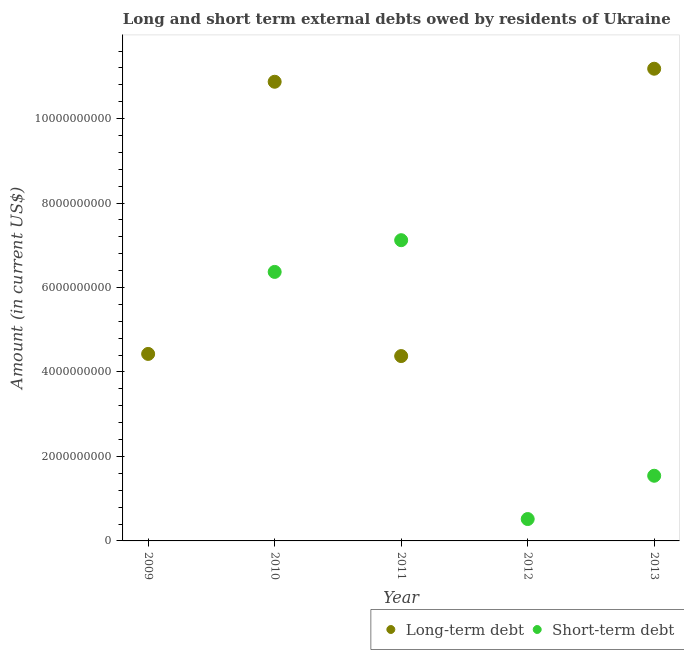What is the long-term debts owed by residents in 2010?
Offer a very short reply. 1.09e+1. Across all years, what is the maximum long-term debts owed by residents?
Provide a succinct answer. 1.12e+1. Across all years, what is the minimum short-term debts owed by residents?
Make the answer very short. 0. In which year was the long-term debts owed by residents maximum?
Keep it short and to the point. 2013. What is the total long-term debts owed by residents in the graph?
Offer a terse response. 3.09e+1. What is the difference between the long-term debts owed by residents in 2009 and that in 2010?
Provide a short and direct response. -6.44e+09. What is the difference between the long-term debts owed by residents in 2010 and the short-term debts owed by residents in 2009?
Your answer should be very brief. 1.09e+1. What is the average long-term debts owed by residents per year?
Your response must be concise. 6.17e+09. In the year 2013, what is the difference between the long-term debts owed by residents and short-term debts owed by residents?
Provide a succinct answer. 9.64e+09. In how many years, is the long-term debts owed by residents greater than 400000000 US$?
Offer a very short reply. 4. What is the ratio of the long-term debts owed by residents in 2010 to that in 2013?
Keep it short and to the point. 0.97. Is the short-term debts owed by residents in 2010 less than that in 2013?
Provide a short and direct response. No. What is the difference between the highest and the second highest long-term debts owed by residents?
Your answer should be very brief. 3.09e+08. What is the difference between the highest and the lowest long-term debts owed by residents?
Provide a succinct answer. 1.12e+1. Does the long-term debts owed by residents monotonically increase over the years?
Your response must be concise. No. Is the long-term debts owed by residents strictly less than the short-term debts owed by residents over the years?
Your answer should be compact. No. How many years are there in the graph?
Give a very brief answer. 5. What is the difference between two consecutive major ticks on the Y-axis?
Offer a very short reply. 2.00e+09. Are the values on the major ticks of Y-axis written in scientific E-notation?
Provide a short and direct response. No. Does the graph contain any zero values?
Ensure brevity in your answer.  Yes. Where does the legend appear in the graph?
Give a very brief answer. Bottom right. What is the title of the graph?
Offer a terse response. Long and short term external debts owed by residents of Ukraine. What is the Amount (in current US$) of Long-term debt in 2009?
Ensure brevity in your answer.  4.43e+09. What is the Amount (in current US$) of Long-term debt in 2010?
Your answer should be very brief. 1.09e+1. What is the Amount (in current US$) in Short-term debt in 2010?
Your answer should be compact. 6.37e+09. What is the Amount (in current US$) in Long-term debt in 2011?
Offer a terse response. 4.38e+09. What is the Amount (in current US$) in Short-term debt in 2011?
Provide a succinct answer. 7.12e+09. What is the Amount (in current US$) in Long-term debt in 2012?
Ensure brevity in your answer.  0. What is the Amount (in current US$) in Short-term debt in 2012?
Provide a short and direct response. 5.18e+08. What is the Amount (in current US$) in Long-term debt in 2013?
Give a very brief answer. 1.12e+1. What is the Amount (in current US$) of Short-term debt in 2013?
Keep it short and to the point. 1.54e+09. Across all years, what is the maximum Amount (in current US$) in Long-term debt?
Provide a succinct answer. 1.12e+1. Across all years, what is the maximum Amount (in current US$) of Short-term debt?
Provide a succinct answer. 7.12e+09. Across all years, what is the minimum Amount (in current US$) in Long-term debt?
Ensure brevity in your answer.  0. Across all years, what is the minimum Amount (in current US$) in Short-term debt?
Make the answer very short. 0. What is the total Amount (in current US$) in Long-term debt in the graph?
Make the answer very short. 3.09e+1. What is the total Amount (in current US$) in Short-term debt in the graph?
Your response must be concise. 1.56e+1. What is the difference between the Amount (in current US$) of Long-term debt in 2009 and that in 2010?
Provide a short and direct response. -6.44e+09. What is the difference between the Amount (in current US$) in Long-term debt in 2009 and that in 2011?
Offer a terse response. 5.08e+07. What is the difference between the Amount (in current US$) of Long-term debt in 2009 and that in 2013?
Offer a terse response. -6.75e+09. What is the difference between the Amount (in current US$) of Long-term debt in 2010 and that in 2011?
Your answer should be compact. 6.50e+09. What is the difference between the Amount (in current US$) of Short-term debt in 2010 and that in 2011?
Offer a terse response. -7.51e+08. What is the difference between the Amount (in current US$) of Short-term debt in 2010 and that in 2012?
Offer a very short reply. 5.85e+09. What is the difference between the Amount (in current US$) of Long-term debt in 2010 and that in 2013?
Offer a terse response. -3.09e+08. What is the difference between the Amount (in current US$) in Short-term debt in 2010 and that in 2013?
Your answer should be compact. 4.83e+09. What is the difference between the Amount (in current US$) of Short-term debt in 2011 and that in 2012?
Offer a very short reply. 6.60e+09. What is the difference between the Amount (in current US$) of Long-term debt in 2011 and that in 2013?
Ensure brevity in your answer.  -6.80e+09. What is the difference between the Amount (in current US$) of Short-term debt in 2011 and that in 2013?
Give a very brief answer. 5.58e+09. What is the difference between the Amount (in current US$) of Short-term debt in 2012 and that in 2013?
Ensure brevity in your answer.  -1.02e+09. What is the difference between the Amount (in current US$) in Long-term debt in 2009 and the Amount (in current US$) in Short-term debt in 2010?
Ensure brevity in your answer.  -1.94e+09. What is the difference between the Amount (in current US$) of Long-term debt in 2009 and the Amount (in current US$) of Short-term debt in 2011?
Provide a short and direct response. -2.69e+09. What is the difference between the Amount (in current US$) in Long-term debt in 2009 and the Amount (in current US$) in Short-term debt in 2012?
Your answer should be compact. 3.91e+09. What is the difference between the Amount (in current US$) of Long-term debt in 2009 and the Amount (in current US$) of Short-term debt in 2013?
Offer a very short reply. 2.88e+09. What is the difference between the Amount (in current US$) of Long-term debt in 2010 and the Amount (in current US$) of Short-term debt in 2011?
Your answer should be very brief. 3.75e+09. What is the difference between the Amount (in current US$) of Long-term debt in 2010 and the Amount (in current US$) of Short-term debt in 2012?
Your response must be concise. 1.04e+1. What is the difference between the Amount (in current US$) of Long-term debt in 2010 and the Amount (in current US$) of Short-term debt in 2013?
Make the answer very short. 9.33e+09. What is the difference between the Amount (in current US$) of Long-term debt in 2011 and the Amount (in current US$) of Short-term debt in 2012?
Your answer should be compact. 3.86e+09. What is the difference between the Amount (in current US$) of Long-term debt in 2011 and the Amount (in current US$) of Short-term debt in 2013?
Provide a succinct answer. 2.83e+09. What is the average Amount (in current US$) in Long-term debt per year?
Ensure brevity in your answer.  6.17e+09. What is the average Amount (in current US$) in Short-term debt per year?
Ensure brevity in your answer.  3.11e+09. In the year 2010, what is the difference between the Amount (in current US$) in Long-term debt and Amount (in current US$) in Short-term debt?
Keep it short and to the point. 4.50e+09. In the year 2011, what is the difference between the Amount (in current US$) of Long-term debt and Amount (in current US$) of Short-term debt?
Give a very brief answer. -2.74e+09. In the year 2013, what is the difference between the Amount (in current US$) in Long-term debt and Amount (in current US$) in Short-term debt?
Give a very brief answer. 9.64e+09. What is the ratio of the Amount (in current US$) of Long-term debt in 2009 to that in 2010?
Keep it short and to the point. 0.41. What is the ratio of the Amount (in current US$) of Long-term debt in 2009 to that in 2011?
Offer a very short reply. 1.01. What is the ratio of the Amount (in current US$) in Long-term debt in 2009 to that in 2013?
Provide a short and direct response. 0.4. What is the ratio of the Amount (in current US$) of Long-term debt in 2010 to that in 2011?
Ensure brevity in your answer.  2.48. What is the ratio of the Amount (in current US$) of Short-term debt in 2010 to that in 2011?
Provide a short and direct response. 0.89. What is the ratio of the Amount (in current US$) of Short-term debt in 2010 to that in 2012?
Provide a short and direct response. 12.3. What is the ratio of the Amount (in current US$) in Long-term debt in 2010 to that in 2013?
Provide a short and direct response. 0.97. What is the ratio of the Amount (in current US$) in Short-term debt in 2010 to that in 2013?
Ensure brevity in your answer.  4.13. What is the ratio of the Amount (in current US$) of Short-term debt in 2011 to that in 2012?
Offer a terse response. 13.75. What is the ratio of the Amount (in current US$) of Long-term debt in 2011 to that in 2013?
Provide a short and direct response. 0.39. What is the ratio of the Amount (in current US$) in Short-term debt in 2011 to that in 2013?
Your answer should be compact. 4.62. What is the ratio of the Amount (in current US$) of Short-term debt in 2012 to that in 2013?
Provide a succinct answer. 0.34. What is the difference between the highest and the second highest Amount (in current US$) in Long-term debt?
Provide a succinct answer. 3.09e+08. What is the difference between the highest and the second highest Amount (in current US$) in Short-term debt?
Your answer should be compact. 7.51e+08. What is the difference between the highest and the lowest Amount (in current US$) in Long-term debt?
Keep it short and to the point. 1.12e+1. What is the difference between the highest and the lowest Amount (in current US$) of Short-term debt?
Offer a very short reply. 7.12e+09. 